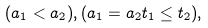<formula> <loc_0><loc_0><loc_500><loc_500>( a _ { 1 } < a _ { 2 } ) , ( a _ { 1 } = a _ { 2 } t _ { 1 } \leq t _ { 2 } ) ,</formula> 